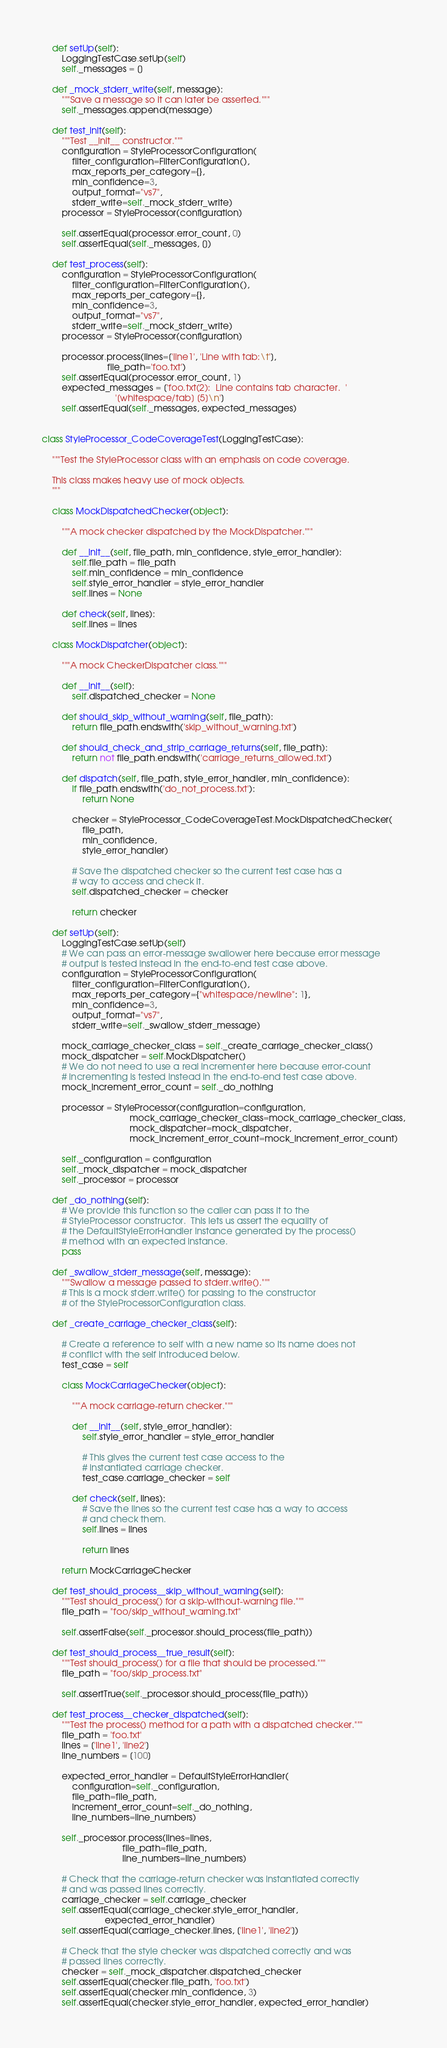Convert code to text. <code><loc_0><loc_0><loc_500><loc_500><_Python_>
    def setUp(self):
        LoggingTestCase.setUp(self)
        self._messages = []

    def _mock_stderr_write(self, message):
        """Save a message so it can later be asserted."""
        self._messages.append(message)

    def test_init(self):
        """Test __init__ constructor."""
        configuration = StyleProcessorConfiguration(
            filter_configuration=FilterConfiguration(),
            max_reports_per_category={},
            min_confidence=3,
            output_format="vs7",
            stderr_write=self._mock_stderr_write)
        processor = StyleProcessor(configuration)

        self.assertEqual(processor.error_count, 0)
        self.assertEqual(self._messages, [])

    def test_process(self):
        configuration = StyleProcessorConfiguration(
            filter_configuration=FilterConfiguration(),
            max_reports_per_category={},
            min_confidence=3,
            output_format="vs7",
            stderr_write=self._mock_stderr_write)
        processor = StyleProcessor(configuration)

        processor.process(lines=['line1', 'Line with tab:\t'],
                          file_path='foo.txt')
        self.assertEqual(processor.error_count, 1)
        expected_messages = ['foo.txt(2):  Line contains tab character.  '
                             '[whitespace/tab] [5]\n']
        self.assertEqual(self._messages, expected_messages)


class StyleProcessor_CodeCoverageTest(LoggingTestCase):

    """Test the StyleProcessor class with an emphasis on code coverage.

    This class makes heavy use of mock objects.
    """

    class MockDispatchedChecker(object):

        """A mock checker dispatched by the MockDispatcher."""

        def __init__(self, file_path, min_confidence, style_error_handler):
            self.file_path = file_path
            self.min_confidence = min_confidence
            self.style_error_handler = style_error_handler
            self.lines = None

        def check(self, lines):
            self.lines = lines

    class MockDispatcher(object):

        """A mock CheckerDispatcher class."""

        def __init__(self):
            self.dispatched_checker = None

        def should_skip_without_warning(self, file_path):
            return file_path.endswith('skip_without_warning.txt')

        def should_check_and_strip_carriage_returns(self, file_path):
            return not file_path.endswith('carriage_returns_allowed.txt')

        def dispatch(self, file_path, style_error_handler, min_confidence):
            if file_path.endswith('do_not_process.txt'):
                return None

            checker = StyleProcessor_CodeCoverageTest.MockDispatchedChecker(
                file_path,
                min_confidence,
                style_error_handler)

            # Save the dispatched checker so the current test case has a
            # way to access and check it.
            self.dispatched_checker = checker

            return checker

    def setUp(self):
        LoggingTestCase.setUp(self)
        # We can pass an error-message swallower here because error message
        # output is tested instead in the end-to-end test case above.
        configuration = StyleProcessorConfiguration(
            filter_configuration=FilterConfiguration(),
            max_reports_per_category={"whitespace/newline": 1},
            min_confidence=3,
            output_format="vs7",
            stderr_write=self._swallow_stderr_message)

        mock_carriage_checker_class = self._create_carriage_checker_class()
        mock_dispatcher = self.MockDispatcher()
        # We do not need to use a real incrementer here because error-count
        # incrementing is tested instead in the end-to-end test case above.
        mock_increment_error_count = self._do_nothing

        processor = StyleProcessor(configuration=configuration,
                                   mock_carriage_checker_class=mock_carriage_checker_class,
                                   mock_dispatcher=mock_dispatcher,
                                   mock_increment_error_count=mock_increment_error_count)

        self._configuration = configuration
        self._mock_dispatcher = mock_dispatcher
        self._processor = processor

    def _do_nothing(self):
        # We provide this function so the caller can pass it to the
        # StyleProcessor constructor.  This lets us assert the equality of
        # the DefaultStyleErrorHandler instance generated by the process()
        # method with an expected instance.
        pass

    def _swallow_stderr_message(self, message):
        """Swallow a message passed to stderr.write()."""
        # This is a mock stderr.write() for passing to the constructor
        # of the StyleProcessorConfiguration class.

    def _create_carriage_checker_class(self):

        # Create a reference to self with a new name so its name does not
        # conflict with the self introduced below.
        test_case = self

        class MockCarriageChecker(object):

            """A mock carriage-return checker."""

            def __init__(self, style_error_handler):
                self.style_error_handler = style_error_handler

                # This gives the current test case access to the
                # instantiated carriage checker.
                test_case.carriage_checker = self

            def check(self, lines):
                # Save the lines so the current test case has a way to access
                # and check them.
                self.lines = lines

                return lines

        return MockCarriageChecker

    def test_should_process__skip_without_warning(self):
        """Test should_process() for a skip-without-warning file."""
        file_path = "foo/skip_without_warning.txt"

        self.assertFalse(self._processor.should_process(file_path))

    def test_should_process__true_result(self):
        """Test should_process() for a file that should be processed."""
        file_path = "foo/skip_process.txt"

        self.assertTrue(self._processor.should_process(file_path))

    def test_process__checker_dispatched(self):
        """Test the process() method for a path with a dispatched checker."""
        file_path = 'foo.txt'
        lines = ['line1', 'line2']
        line_numbers = [100]

        expected_error_handler = DefaultStyleErrorHandler(
            configuration=self._configuration,
            file_path=file_path,
            increment_error_count=self._do_nothing,
            line_numbers=line_numbers)

        self._processor.process(lines=lines,
                                file_path=file_path,
                                line_numbers=line_numbers)

        # Check that the carriage-return checker was instantiated correctly
        # and was passed lines correctly.
        carriage_checker = self.carriage_checker
        self.assertEqual(carriage_checker.style_error_handler,
                         expected_error_handler)
        self.assertEqual(carriage_checker.lines, ['line1', 'line2'])

        # Check that the style checker was dispatched correctly and was
        # passed lines correctly.
        checker = self._mock_dispatcher.dispatched_checker
        self.assertEqual(checker.file_path, 'foo.txt')
        self.assertEqual(checker.min_confidence, 3)
        self.assertEqual(checker.style_error_handler, expected_error_handler)
</code> 